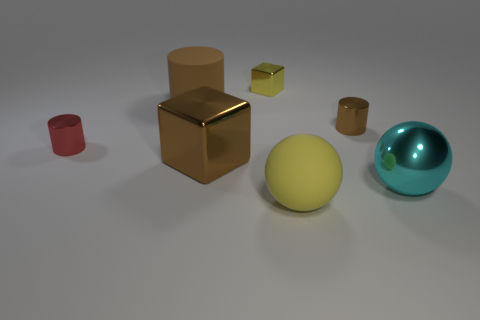Subtract all green cubes. How many brown cylinders are left? 2 Subtract all small metallic cylinders. How many cylinders are left? 1 Subtract 1 cylinders. How many cylinders are left? 2 Add 1 cylinders. How many objects exist? 8 Subtract all spheres. How many objects are left? 5 Add 3 large brown cylinders. How many large brown cylinders are left? 4 Add 7 large yellow objects. How many large yellow objects exist? 8 Subtract 0 gray cubes. How many objects are left? 7 Subtract all cyan cylinders. Subtract all cyan spheres. How many cylinders are left? 3 Subtract all big yellow metal cylinders. Subtract all shiny cylinders. How many objects are left? 5 